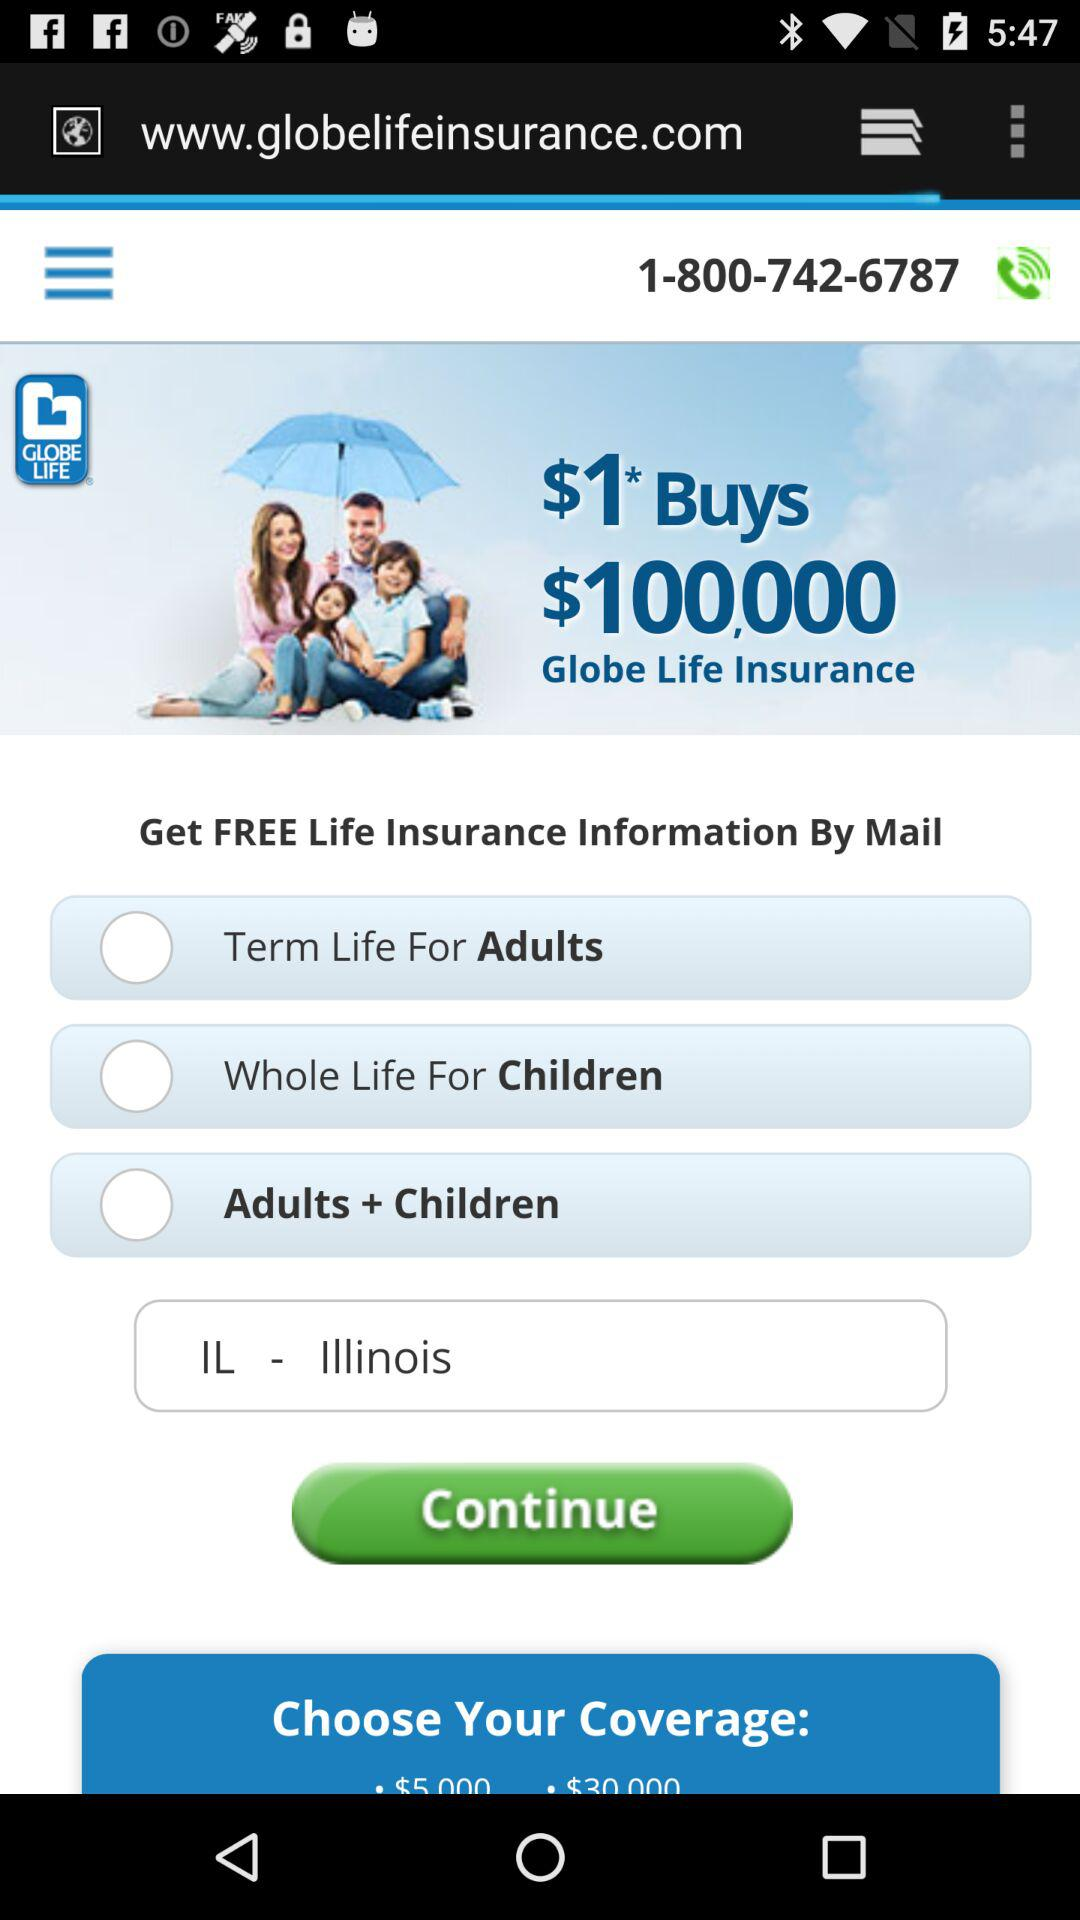How many coverage options are there?
Answer the question using a single word or phrase. 3 